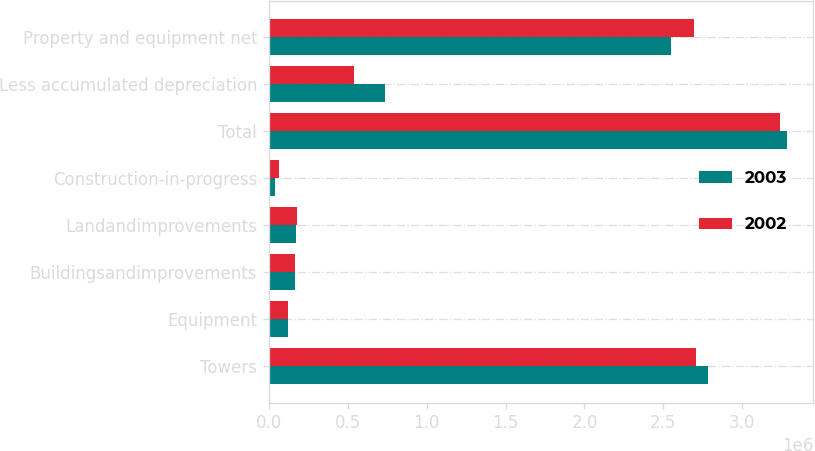<chart> <loc_0><loc_0><loc_500><loc_500><stacked_bar_chart><ecel><fcel>Towers<fcel>Equipment<fcel>Buildingsandimprovements<fcel>Landandimprovements<fcel>Construction-in-progress<fcel>Total<fcel>Less accumulated depreciation<fcel>Property and equipment net<nl><fcel>2003<fcel>2.78456e+06<fcel>121780<fcel>166068<fcel>173619<fcel>38683<fcel>3.28471e+06<fcel>738189<fcel>2.54652e+06<nl><fcel>2002<fcel>2.706e+06<fcel>121238<fcel>168445<fcel>176990<fcel>63755<fcel>3.23643e+06<fcel>541434<fcel>2.695e+06<nl></chart> 